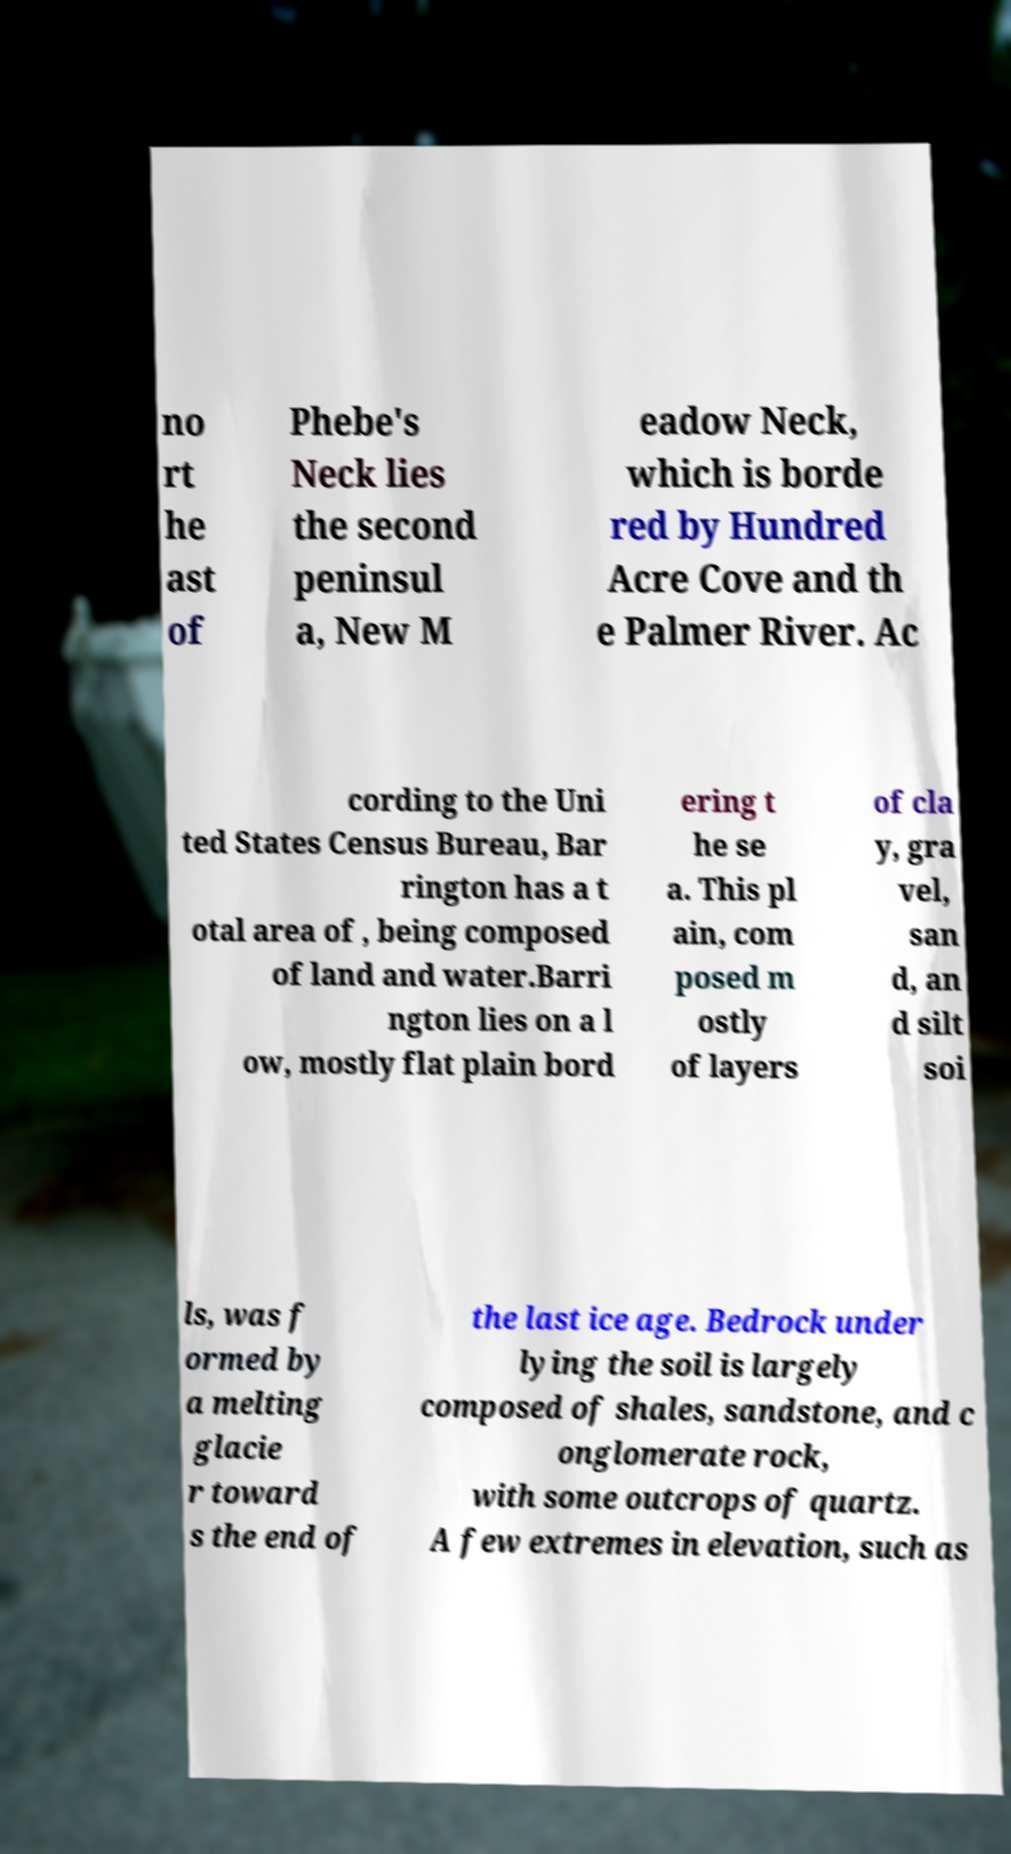Can you read and provide the text displayed in the image?This photo seems to have some interesting text. Can you extract and type it out for me? no rt he ast of Phebe's Neck lies the second peninsul a, New M eadow Neck, which is borde red by Hundred Acre Cove and th e Palmer River. Ac cording to the Uni ted States Census Bureau, Bar rington has a t otal area of , being composed of land and water.Barri ngton lies on a l ow, mostly flat plain bord ering t he se a. This pl ain, com posed m ostly of layers of cla y, gra vel, san d, an d silt soi ls, was f ormed by a melting glacie r toward s the end of the last ice age. Bedrock under lying the soil is largely composed of shales, sandstone, and c onglomerate rock, with some outcrops of quartz. A few extremes in elevation, such as 